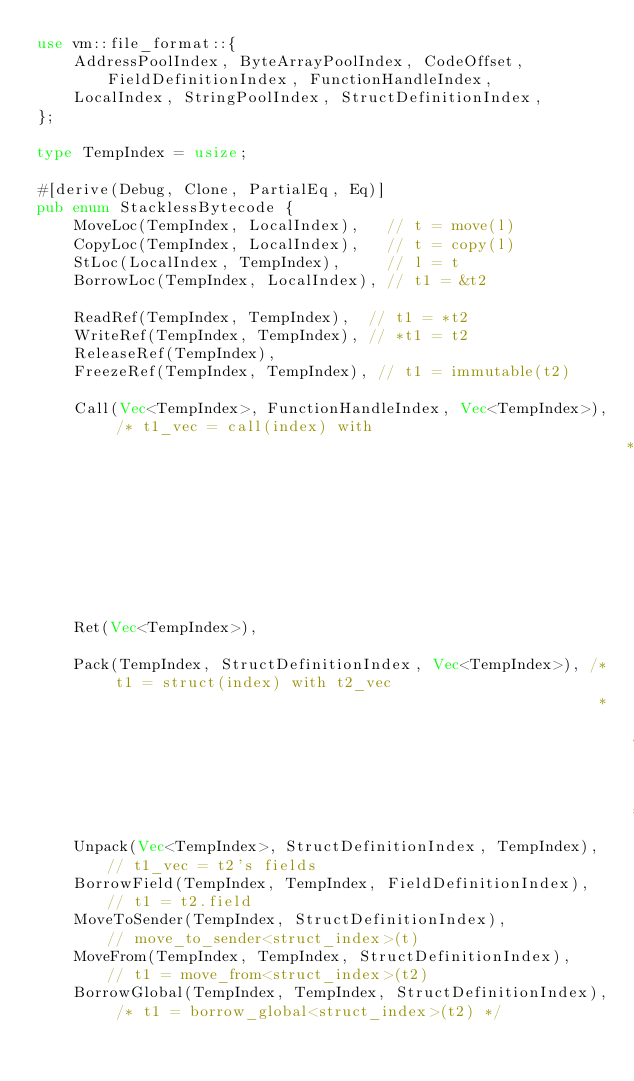Convert code to text. <code><loc_0><loc_0><loc_500><loc_500><_Rust_>use vm::file_format::{
    AddressPoolIndex, ByteArrayPoolIndex, CodeOffset, FieldDefinitionIndex, FunctionHandleIndex,
    LocalIndex, StringPoolIndex, StructDefinitionIndex,
};

type TempIndex = usize;

#[derive(Debug, Clone, PartialEq, Eq)]
pub enum StacklessBytecode {
    MoveLoc(TempIndex, LocalIndex),   // t = move(l)
    CopyLoc(TempIndex, LocalIndex),   // t = copy(l)
    StLoc(LocalIndex, TempIndex),     // l = t
    BorrowLoc(TempIndex, LocalIndex), // t1 = &t2

    ReadRef(TempIndex, TempIndex),  // t1 = *t2
    WriteRef(TempIndex, TempIndex), // *t1 = t2
    ReleaseRef(TempIndex),
    FreezeRef(TempIndex, TempIndex), // t1 = immutable(t2)

    Call(Vec<TempIndex>, FunctionHandleIndex, Vec<TempIndex>), /* t1_vec = call(index) with
                                                                * t2_vec as parameters */
    Ret(Vec<TempIndex>),

    Pack(TempIndex, StructDefinitionIndex, Vec<TempIndex>), /* t1 = struct(index) with t2_vec
                                                             * as fields */
    Unpack(Vec<TempIndex>, StructDefinitionIndex, TempIndex), // t1_vec = t2's fields
    BorrowField(TempIndex, TempIndex, FieldDefinitionIndex),  // t1 = t2.field
    MoveToSender(TempIndex, StructDefinitionIndex),           // move_to_sender<struct_index>(t)
    MoveFrom(TempIndex, TempIndex, StructDefinitionIndex),    // t1 = move_from<struct_index>(t2)
    BorrowGlobal(TempIndex, TempIndex, StructDefinitionIndex), /* t1 = borrow_global<struct_index>(t2) */</code> 